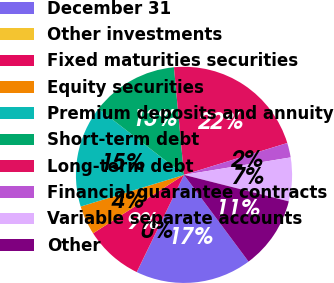Convert chart. <chart><loc_0><loc_0><loc_500><loc_500><pie_chart><fcel>December 31<fcel>Other investments<fcel>Fixed maturities securities<fcel>Equity securities<fcel>Premium deposits and annuity<fcel>Short-term debt<fcel>Long-term debt<fcel>Financial guarantee contracts<fcel>Variable separate accounts<fcel>Other<nl><fcel>17.38%<fcel>0.01%<fcel>8.7%<fcel>4.36%<fcel>15.21%<fcel>13.04%<fcel>21.72%<fcel>2.18%<fcel>6.53%<fcel>10.87%<nl></chart> 